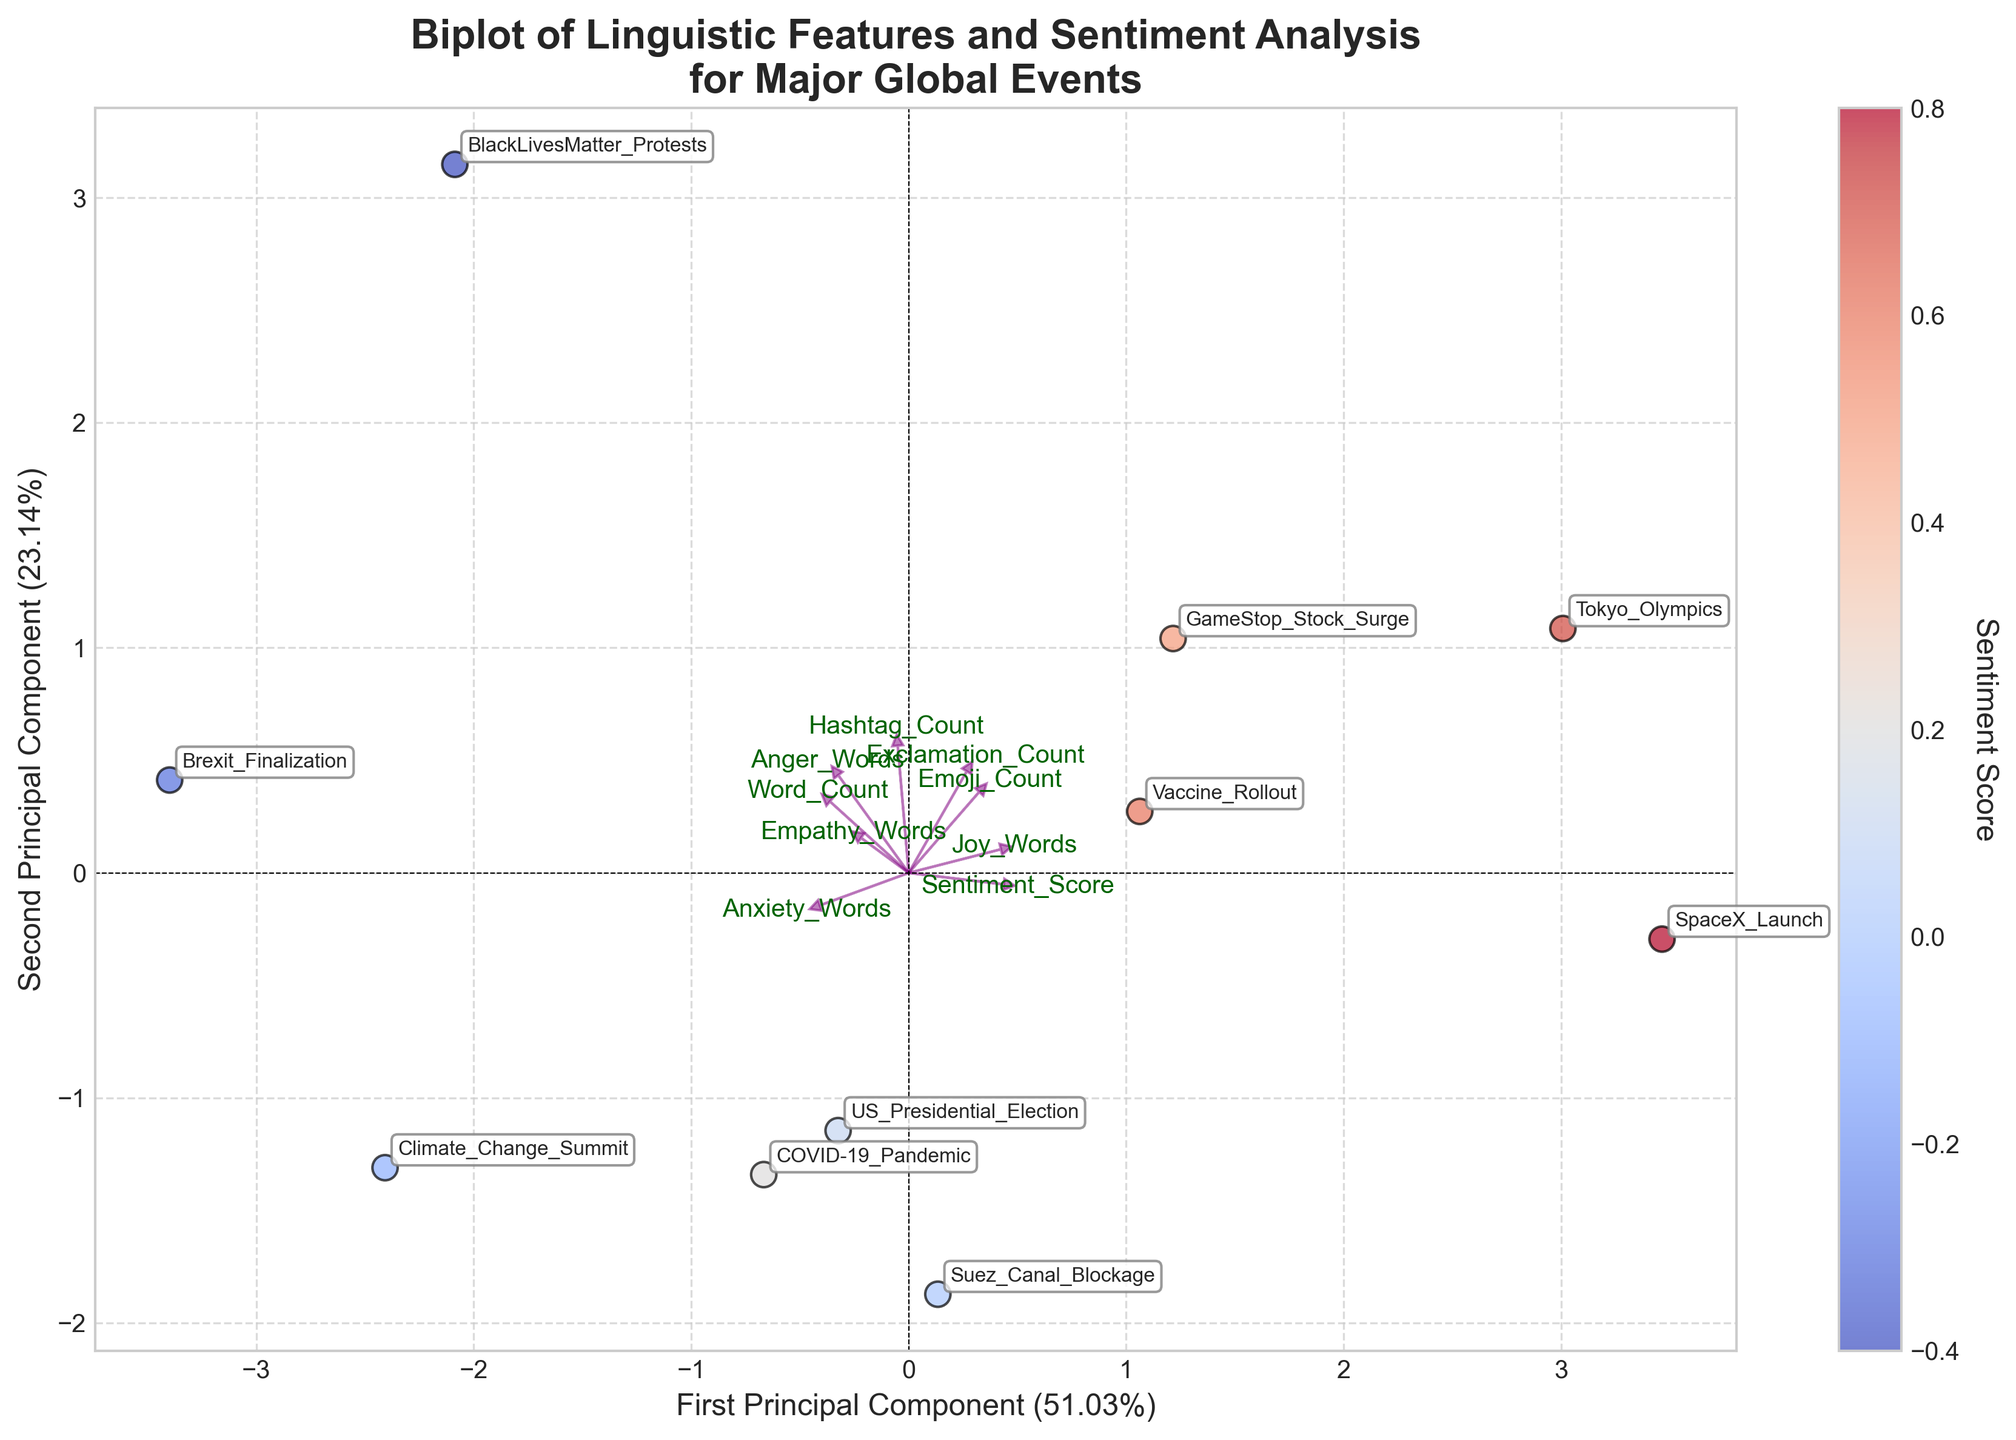How many data points are shown in the Biplot? There are 10 events listed in the dataset, which means there should be 10 data points plotted on the Biplot. Each data point represents one event.
Answer: 10 Which event has the highest sentiment score? The event with the highest sentiment score should be the one located on the farthest positive end of the color scale, represented by the warmest (reddest) color. The tooltip or label near the data point shows that "SpaceX_Launch" has the highest sentiment score of 0.8.
Answer: SpaceX_Launch What are the labels for the axes in the Biplot? The x-axis is labeled "First Principal Component" and the y-axis is labeled "Second Principal Component." The annotations show the percentage of variance explained by each principal component.
Answer: First Principal Component, Second Principal Component Which events have higher sentiment scores than the US Presidential Election event? The US Presidential Election has a sentiment score of 0.1, according to the dataset. In the plot, events with higher sentiment scores will be represented by warmer colors (yellow to red) and should have labels with sentiment scores greater than 0.1. The events that meet these criteria are "Tokyo_Olympics," "SpaceX_Launch," "GameStop_Stock_Surge," and "Vaccine_Rollout."
Answer: Tokyo_Olympics, SpaceX_Launch, GameStop_Stock_Surge, Vaccine_Rollout Which linguistic feature vector has the largest contribution to the first principal component? The length and direction of the feature vectors (purple arrows) show their contribution. The vector pointing farthest in the x-direction represents the largest contribution. Based on the plot, "Word_Count" has the longest vector in the direction of the First Principal Component.
Answer: Word_Count What is the relationship between "Joy_Words" and sentiment scores from the Biplot? The direction and length of the "Joy_Words" vector show its correlation with sentiment scores in the Biplot. "Joy_Words" vector points in the positive direction of both principal components, indicating a positive association with higher sentiment scores. Data points that are associated with high sentiment scores (reddish color) appear to align with the "Joy_Words" vector.
Answer: Positive association Compare the use of hashtags in the BlackLivesMatter Protests and Tokyo Olympics based on the Biplot. By comparing the positions of "BlackLivesMatter_Protests" and "Tokyo_Olympics" in relation to the "Hashtag_Count" vector (purple arrow), it's observed that "BlackLivesMatter_Protests" is closer to or in the direction of the "Hashtag_Count" vector, indicating a higher use of hashtags compared to "Tokyo_Olympics."
Answer: Higher in BlackLivesMatter_Protests Which events have a higher empathy word usage than anxiety word usage based on the Biplot? Identify the vectors for "Empathy_Words" and "Anxiety_Words." Then locate events that are closer to or further in the direction of the "Empathy_Words" vector and relatively farther from the "Anxiety_Words" vector. According to the visual data, "COVID-19_Pandemic," "BlackLivesMatter_Protests," and "Brexit_Finalization" satisfy this condition.
Answer: COVID-19_Pandemic, BlackLivesMatter_Protests, Brexit_Finalization 